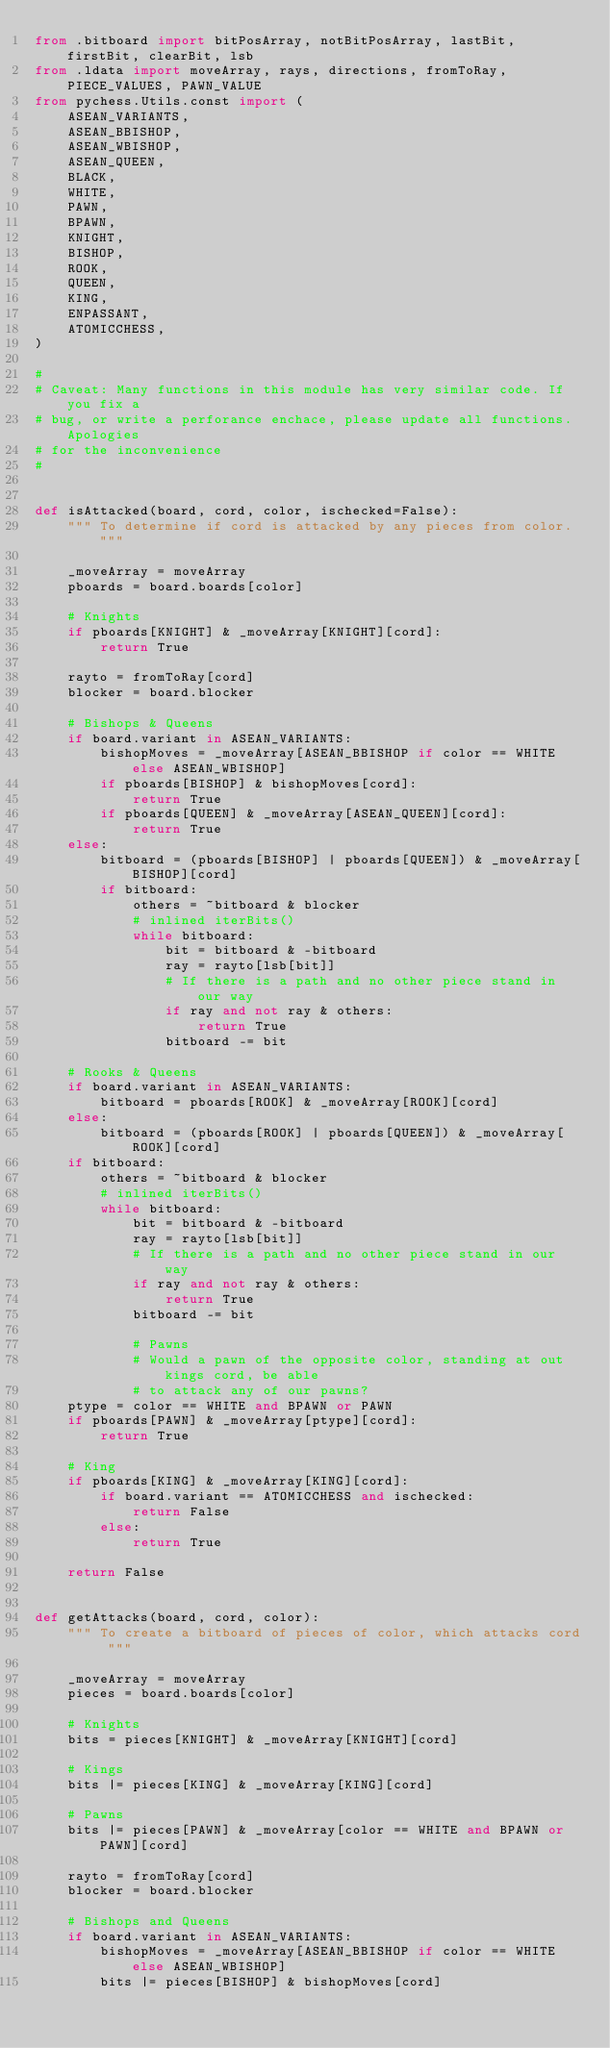Convert code to text. <code><loc_0><loc_0><loc_500><loc_500><_Python_>from .bitboard import bitPosArray, notBitPosArray, lastBit, firstBit, clearBit, lsb
from .ldata import moveArray, rays, directions, fromToRay, PIECE_VALUES, PAWN_VALUE
from pychess.Utils.const import (
    ASEAN_VARIANTS,
    ASEAN_BBISHOP,
    ASEAN_WBISHOP,
    ASEAN_QUEEN,
    BLACK,
    WHITE,
    PAWN,
    BPAWN,
    KNIGHT,
    BISHOP,
    ROOK,
    QUEEN,
    KING,
    ENPASSANT,
    ATOMICCHESS,
)

#
# Caveat: Many functions in this module has very similar code. If you fix a
# bug, or write a perforance enchace, please update all functions. Apologies
# for the inconvenience
#


def isAttacked(board, cord, color, ischecked=False):
    """ To determine if cord is attacked by any pieces from color. """

    _moveArray = moveArray
    pboards = board.boards[color]

    # Knights
    if pboards[KNIGHT] & _moveArray[KNIGHT][cord]:
        return True

    rayto = fromToRay[cord]
    blocker = board.blocker

    # Bishops & Queens
    if board.variant in ASEAN_VARIANTS:
        bishopMoves = _moveArray[ASEAN_BBISHOP if color == WHITE else ASEAN_WBISHOP]
        if pboards[BISHOP] & bishopMoves[cord]:
            return True
        if pboards[QUEEN] & _moveArray[ASEAN_QUEEN][cord]:
            return True
    else:
        bitboard = (pboards[BISHOP] | pboards[QUEEN]) & _moveArray[BISHOP][cord]
        if bitboard:
            others = ~bitboard & blocker
            # inlined iterBits()
            while bitboard:
                bit = bitboard & -bitboard
                ray = rayto[lsb[bit]]
                # If there is a path and no other piece stand in our way
                if ray and not ray & others:
                    return True
                bitboard -= bit

    # Rooks & Queens
    if board.variant in ASEAN_VARIANTS:
        bitboard = pboards[ROOK] & _moveArray[ROOK][cord]
    else:
        bitboard = (pboards[ROOK] | pboards[QUEEN]) & _moveArray[ROOK][cord]
    if bitboard:
        others = ~bitboard & blocker
        # inlined iterBits()
        while bitboard:
            bit = bitboard & -bitboard
            ray = rayto[lsb[bit]]
            # If there is a path and no other piece stand in our way
            if ray and not ray & others:
                return True
            bitboard -= bit

            # Pawns
            # Would a pawn of the opposite color, standing at out kings cord, be able
            # to attack any of our pawns?
    ptype = color == WHITE and BPAWN or PAWN
    if pboards[PAWN] & _moveArray[ptype][cord]:
        return True

    # King
    if pboards[KING] & _moveArray[KING][cord]:
        if board.variant == ATOMICCHESS and ischecked:
            return False
        else:
            return True

    return False


def getAttacks(board, cord, color):
    """ To create a bitboard of pieces of color, which attacks cord """

    _moveArray = moveArray
    pieces = board.boards[color]

    # Knights
    bits = pieces[KNIGHT] & _moveArray[KNIGHT][cord]

    # Kings
    bits |= pieces[KING] & _moveArray[KING][cord]

    # Pawns
    bits |= pieces[PAWN] & _moveArray[color == WHITE and BPAWN or PAWN][cord]

    rayto = fromToRay[cord]
    blocker = board.blocker

    # Bishops and Queens
    if board.variant in ASEAN_VARIANTS:
        bishopMoves = _moveArray[ASEAN_BBISHOP if color == WHITE else ASEAN_WBISHOP]
        bits |= pieces[BISHOP] & bishopMoves[cord]
</code> 